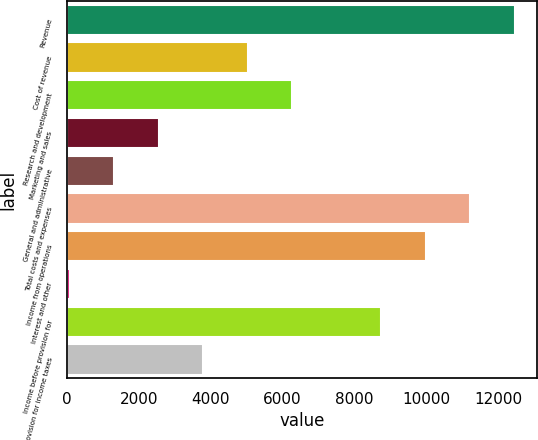<chart> <loc_0><loc_0><loc_500><loc_500><bar_chart><fcel>Revenue<fcel>Cost of revenue<fcel>Research and development<fcel>Marketing and sales<fcel>General and administrative<fcel>Total costs and expenses<fcel>Income from operations<fcel>Interest and other<fcel>Income before provision for<fcel>Provision for income taxes<nl><fcel>12466<fcel>5036.8<fcel>6275<fcel>2560.4<fcel>1322.2<fcel>11227.8<fcel>9989.6<fcel>84<fcel>8751.4<fcel>3798.6<nl></chart> 